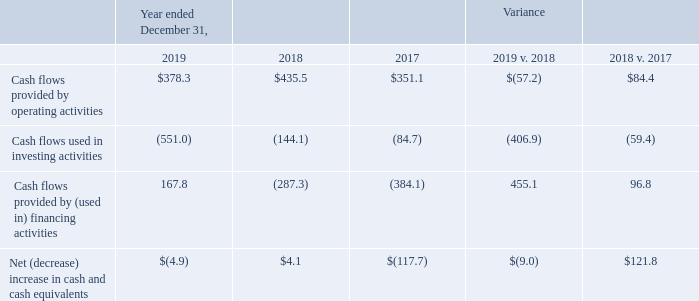Cash Flows
The following table provides a summary of cash flows from operating, investing and financing activities (in millions):
Operating Activities
The $57.2 million decrease in cash provided by operating activities in 2019 compared to 2018 is primarily related to the timing and amount of cash receipts for Trade receivables, net, higher payments primarily related to income taxes and incentive bonus, and the timing of payments for Trade accounts payable and other accrued liabilities. The $84.4 million increase in cash provided by operating activities in 2018 compared to 2017 was primarily related to increased earnings excluding the prior year effect of the Tax Reform Act and the timing and amount of cash receipts for Trade receivables, net.
Investing Activities
The $406.9 million increase in cash used in investing activities in 2019 compared to 2018 is primarily related to our D&B Investment and our acquisition of Compass Analytics. The $59.4 million increase in cash used in investing activities in 2018 compared to 2017 was primarily related to the HeavyWater and Ernst acquisitions and higher capital expenditures in 2018.
Financing Activities
The $455.1 million increase in cash provided by financing activities in 2019 compared to 2018 is primarily related to an incremental borrowing to fund our D&B Investment as well as fewer share repurchases. The $96.8 million decrease in cash used in financing activities in 2018 compared to 2017 was primarily related to tax distributions to BKFS LLC members and the senior notes redemption fee in 2017.
What was the change in operating activities between 2018 and 2019?
Answer scale should be: million. (57.2). What was the change in operating activities between 2017 and 2018? 
Answer scale should be: million. 84.4. Why did investing activities increase between 2017 and 2018? Primarily related to the heavywater and ernst acquisitions and higher capital expenditures in 2018. What was the cash flows provided by operating activities in 2019 as a percentage of the cash flow in 2018?
Answer scale should be: percent. 378.3/435.5
Answer: 86.87. How many years was the Net  increase in cash and cash equivalents positive? 2018
Answer: 1. What was the percentage change in Cash flows provided by operating activities between 2018 and 2019?
Answer scale should be: percent. (378.3-435.5)/435.5
Answer: -13.13. 